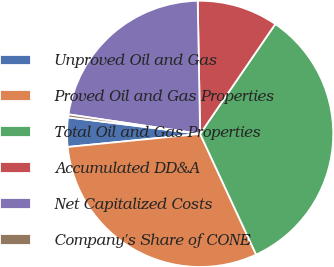Convert chart to OTSL. <chart><loc_0><loc_0><loc_500><loc_500><pie_chart><fcel>Unproved Oil and Gas<fcel>Proved Oil and Gas Properties<fcel>Total Oil and Gas Properties<fcel>Accumulated DD&A<fcel>Net Capitalized Costs<fcel>Company's Share of CONE<nl><fcel>3.55%<fcel>30.34%<fcel>33.53%<fcel>9.84%<fcel>22.37%<fcel>0.36%<nl></chart> 